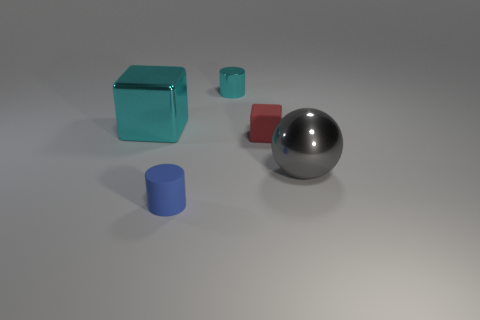Does the metallic thing that is in front of the big block have the same shape as the small rubber thing in front of the small red matte cube?
Offer a very short reply. No. There is a metal sphere that is the same size as the cyan block; what color is it?
Offer a very short reply. Gray. What number of small cyan shiny things are the same shape as the blue rubber thing?
Make the answer very short. 1. What is the shape of the rubber thing behind the cylinder that is in front of the big thing to the left of the small red matte cube?
Provide a short and direct response. Cube. What is the shape of the thing that is the same color as the large cube?
Your response must be concise. Cylinder. What color is the tiny cylinder that is on the right side of the cylinder in front of the metallic object that is in front of the small red block?
Your answer should be very brief. Cyan. Is the blue cylinder the same size as the matte cube?
Provide a succinct answer. Yes. What material is the tiny cylinder that is behind the cyan object on the left side of the blue cylinder?
Your answer should be compact. Metal. Does the blue object have the same shape as the large cyan thing?
Your answer should be compact. No. There is a cyan metallic thing that is to the right of the blue cylinder; how big is it?
Provide a succinct answer. Small. 